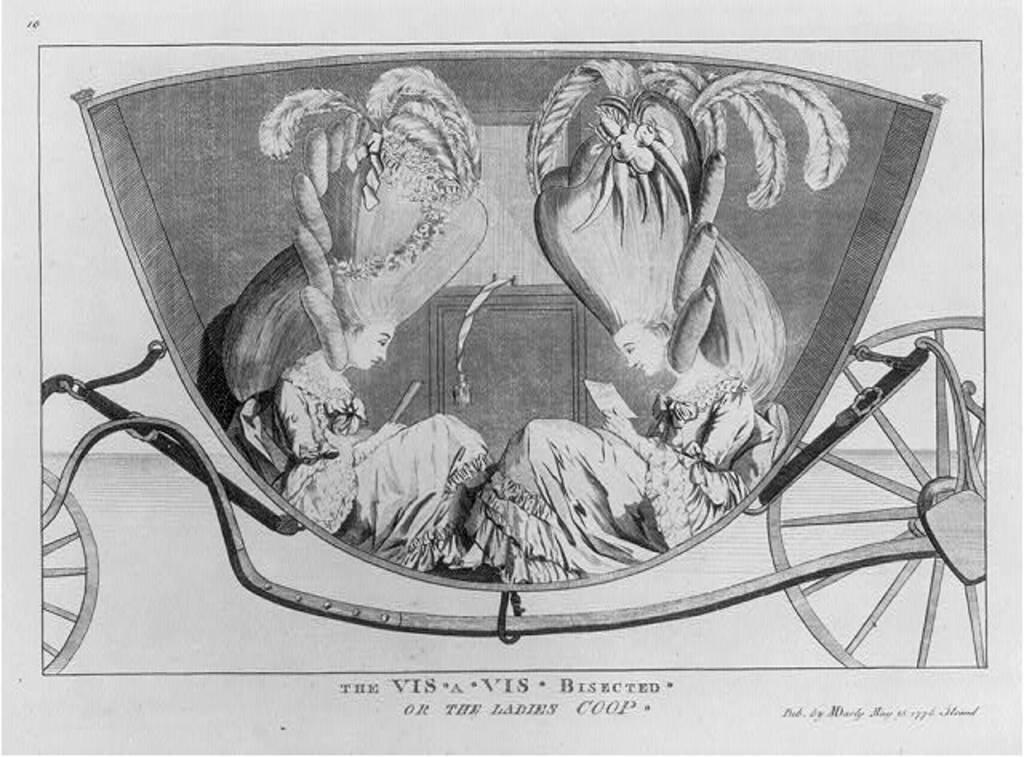Please provide a concise description of this image. In the picture I can see the painting. In the painting I can see two women sitting in the two wheeler and there is a text at the bottom of the picture. 